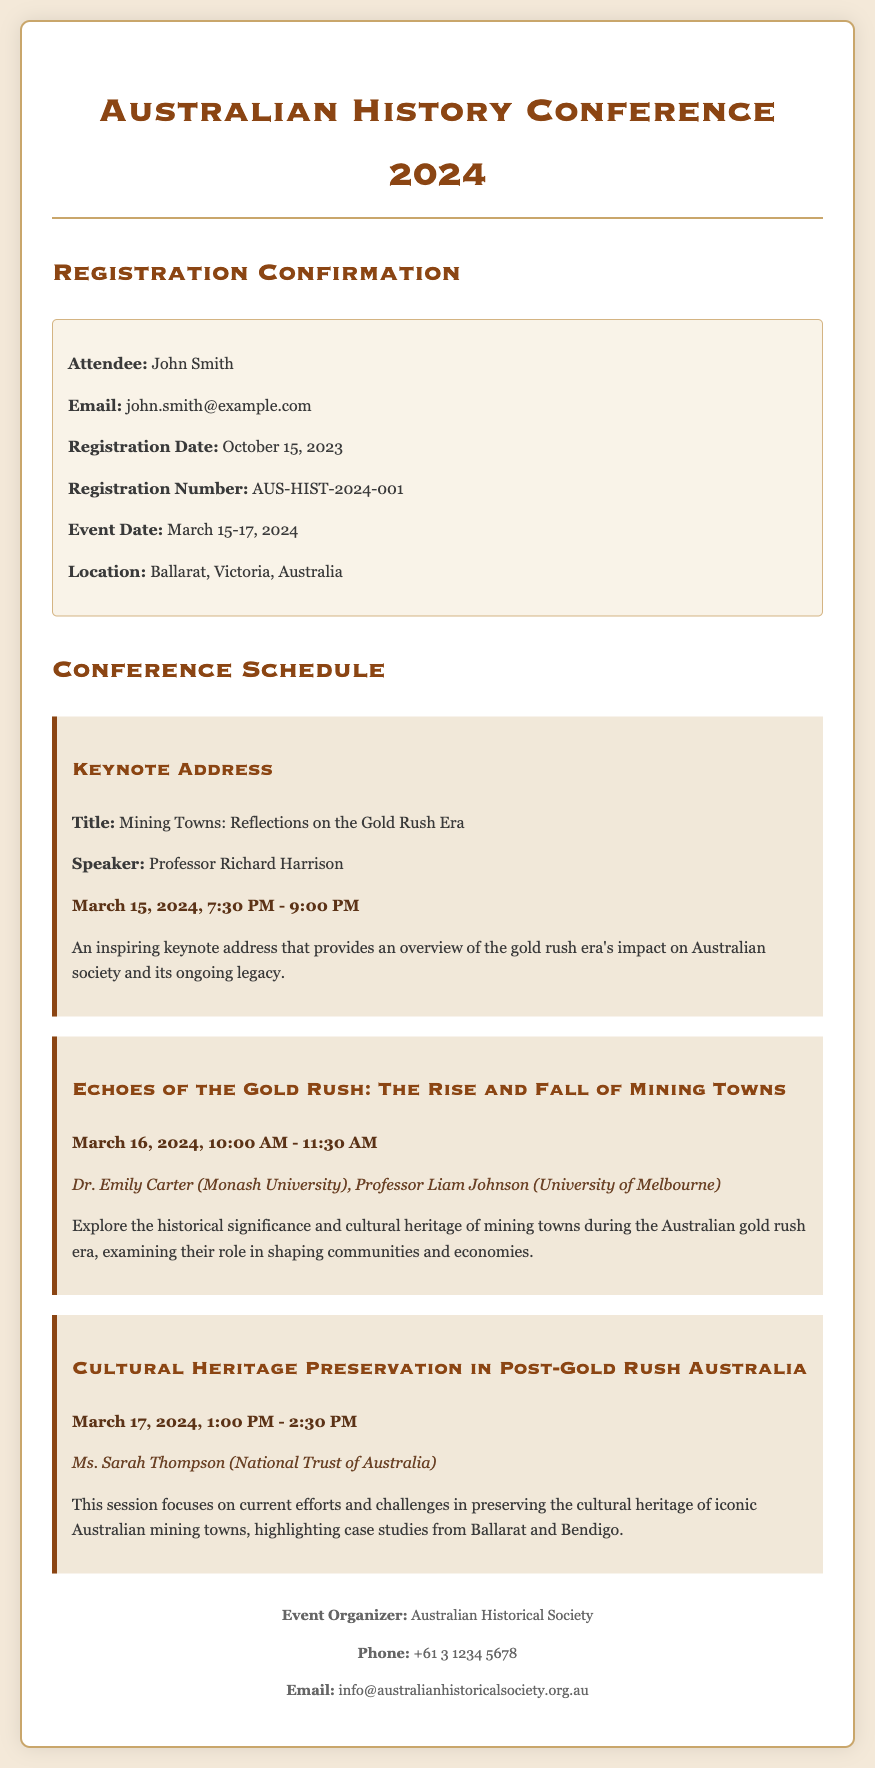What is the title of the keynote address? The title of the keynote address is mentioned in the document, which is "Mining Towns: Reflections on the Gold Rush Era".
Answer: Mining Towns: Reflections on the Gold Rush Era Who is the speaker for the keynote address? The speaker for the keynote address is explicitly stated in the document as Professor Richard Harrison.
Answer: Professor Richard Harrison When is the session on "Echoes of the Gold Rush" scheduled? The scheduling for the session is detailed in the document, indicating it takes place on March 16, 2024, from 10:00 AM to 11:30 AM.
Answer: March 16, 2024, 10:00 AM - 11:30 AM What is the venue for the conference? The document specifies the location of the conference, which is Ballarat, Victoria, Australia.
Answer: Ballarat, Victoria, Australia How many days will the event take place? The event date is listed as March 15-17, 2024, which indicates it spans over three days.
Answer: 3 days What is the registration number for John Smith? The registration number is clearly indicated in the document as AUS-HIST-2024-001.
Answer: AUS-HIST-2024-001 What organization is responsible for organizing the event? The event organizer is mentioned in the document, which is the Australian Historical Society.
Answer: Australian Historical Society What is the focus of the session on March 17, 2024? The focus of the session is outlined in the document, which discusses cultural heritage preservation in post-gold rush Australia.
Answer: Cultural Heritage Preservation in Post-Gold Rush Australia 